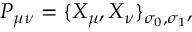Convert formula to latex. <formula><loc_0><loc_0><loc_500><loc_500>P _ { \mu \nu } = \{ X _ { \mu } , X _ { \nu } \} _ { \sigma _ { 0 } , \sigma _ { 1 } } ,</formula> 